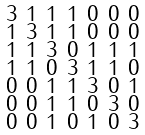Convert formula to latex. <formula><loc_0><loc_0><loc_500><loc_500>\begin{smallmatrix} 3 & 1 & 1 & 1 & 0 & 0 & 0 \\ 1 & 3 & 1 & 1 & 0 & 0 & 0 \\ 1 & 1 & 3 & 0 & 1 & 1 & 1 \\ 1 & 1 & 0 & 3 & 1 & 1 & 0 \\ 0 & 0 & 1 & 1 & 3 & 0 & 1 \\ 0 & 0 & 1 & 1 & 0 & 3 & 0 \\ 0 & 0 & 1 & 0 & 1 & 0 & 3 \end{smallmatrix}</formula> 